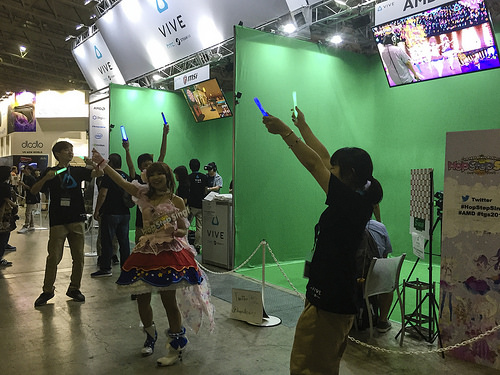<image>
Can you confirm if the man is in front of the woman? No. The man is not in front of the woman. The spatial positioning shows a different relationship between these objects. 